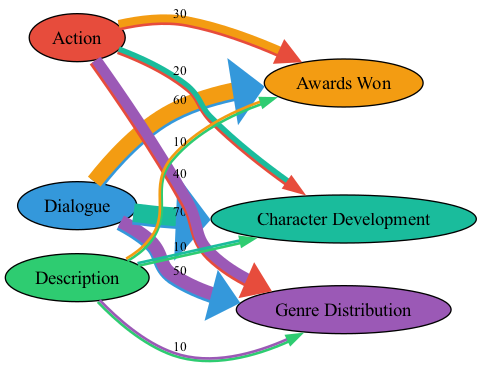What is the total value of "Dialogue" leading to "Awards Won"? The value of "Dialogue" leading to "Awards Won" is shown in the diagram as 60.
Answer: 60 What source contributes the least to "Awards Won"? Comparing the values from "Dialogue" (60), "Action" (30), and "Description" (10), "Description" has the least value of 10 leading to "Awards Won".
Answer: Description How many total elements flow into "Character Development"? The elements flowing into "Character Development" are "Dialogue," "Action," and "Description," which totals three elements.
Answer: 3 What is the total value flowing from "Action" to both "Awards Won" and "Character Development"? The value flowing from "Action" to "Awards Won" is 30 and to "Character Development" is 20, summing these values gives 30 + 20 = 50.
Answer: 50 Which screenplay element has the highest contribution to "Genre Distribution"? Analyzing the values, "Dialogue" has a value of 50, "Action" has 40, and "Description" has 10. "Dialogue" contributes the highest with a value of 50.
Answer: Dialogue What is the combined value of "Description" for "Awards Won" and "Genre Distribution"? "Description" has a value of 10 leading to "Awards Won" and a value of 10 leading to "Genre Distribution." Summing these gives 10 + 10 = 20.
Answer: 20 Which element contributes more to "Character Development," "Dialogue" or "Action"? "Dialogue" contributes 70 to "Character Development," while "Action" contributes only 20. Thus, "Dialogue" contributes more.
Answer: Dialogue What percentage of the "Awards Won" is attributed to "Action"? The total value for "Awards Won" is 60 (Dialogue) + 30 (Action) + 10 (Description) = 100. "Action" contributes 30, which is 30% of 100.
Answer: 30% How many total connections are there from screenplay elements to their respective targets? The connections are from "Dialogue," "Action," and "Description" to "Awards Won," "Genre Distribution," and "Character Development," resulting in a total of 9 connections.
Answer: 9 